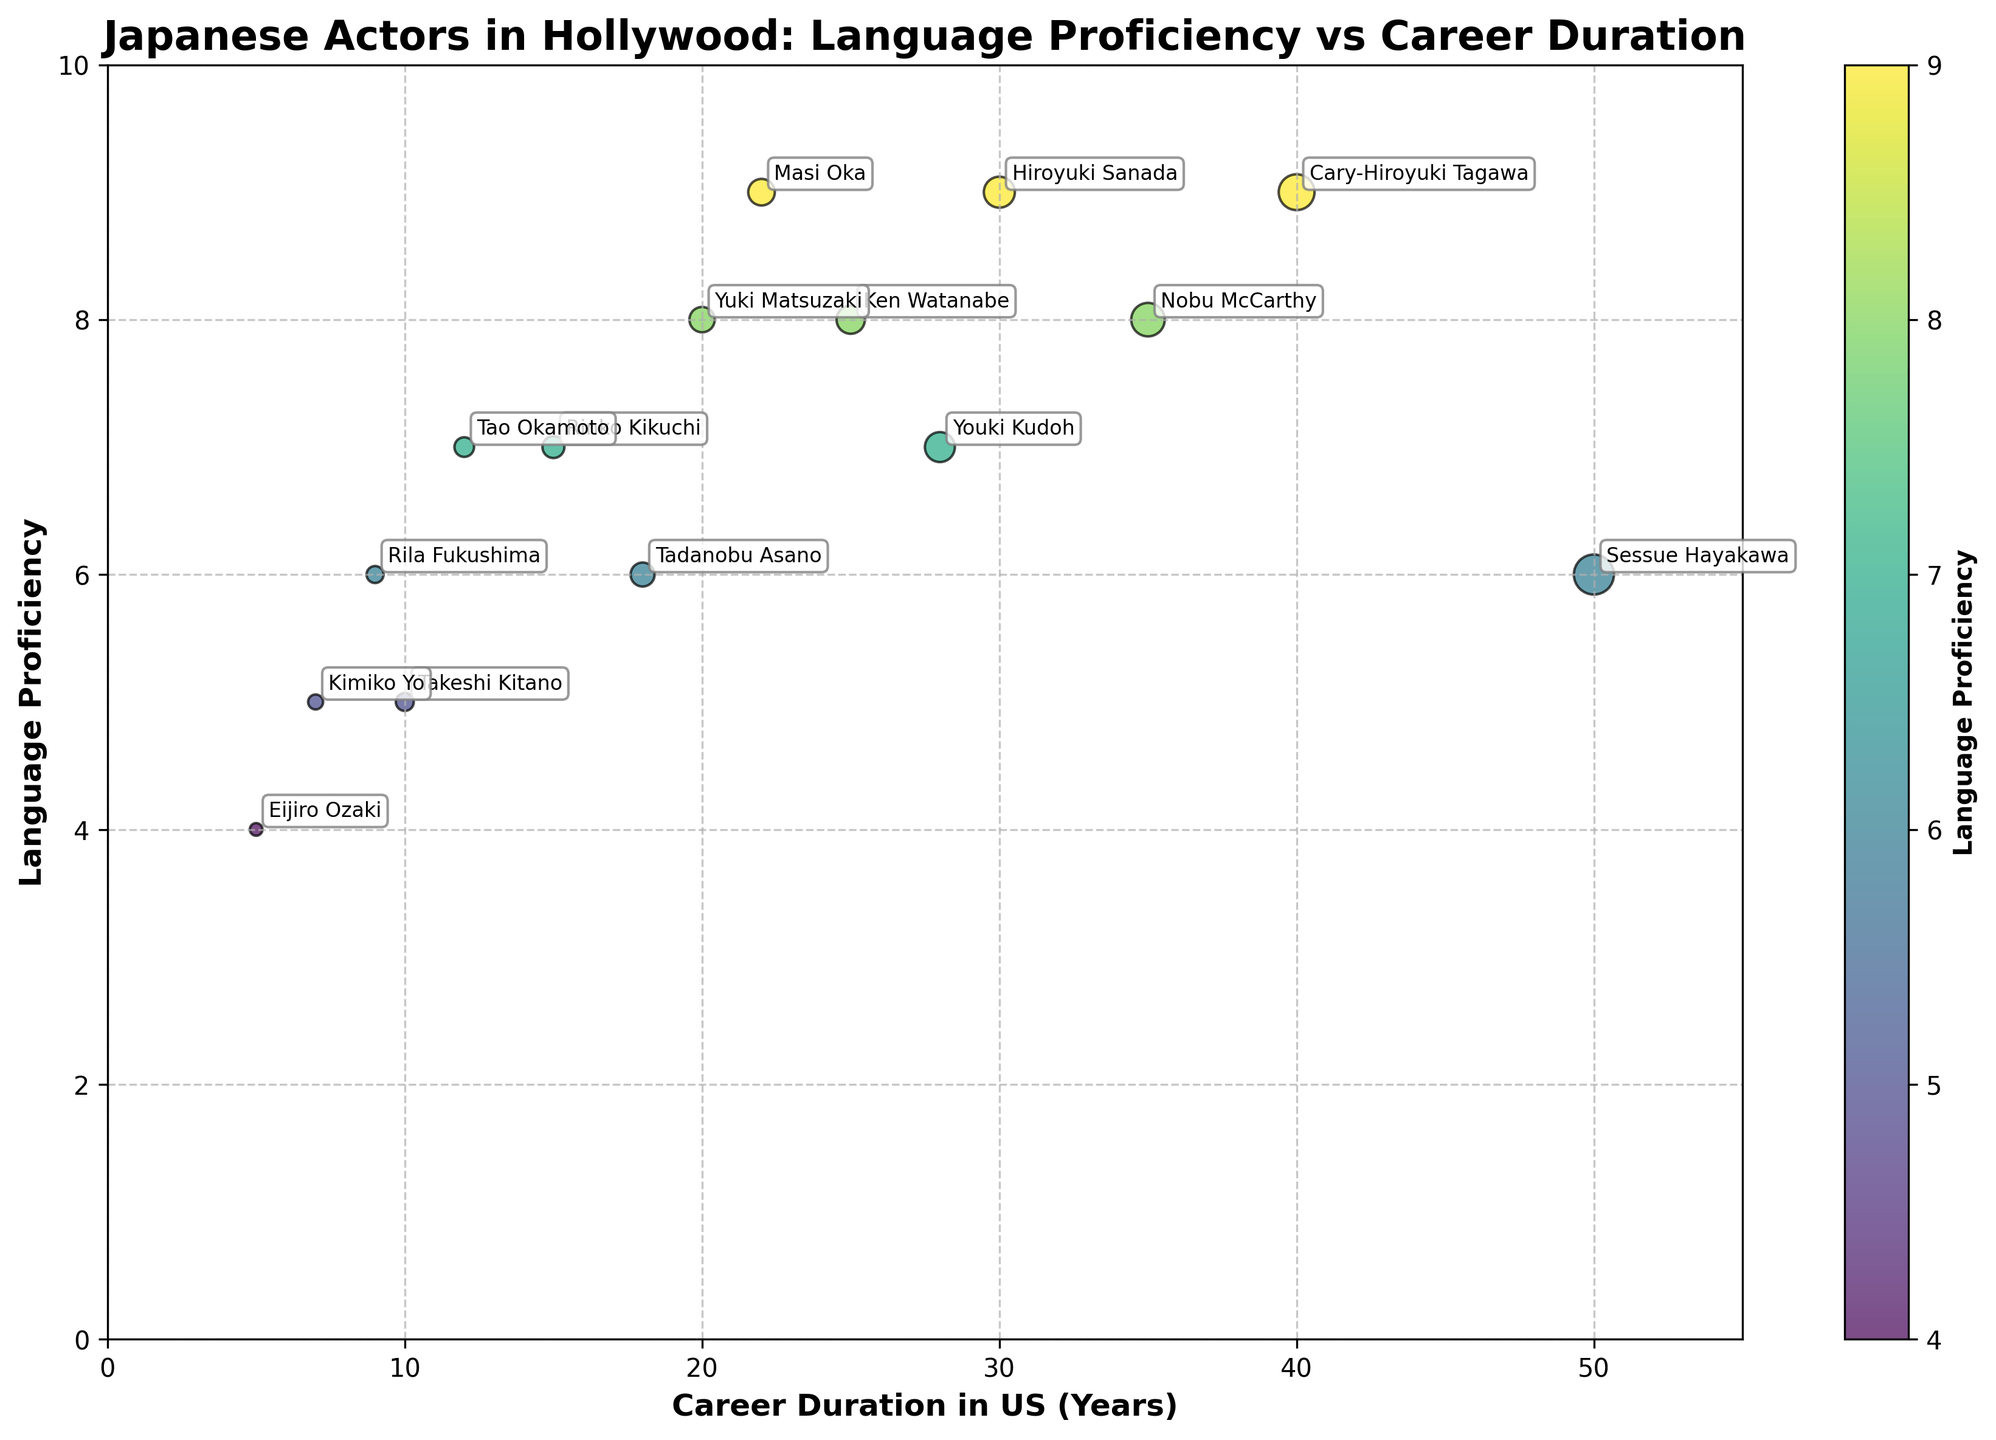How many data points are present in the figure? By looking at the scatter plot, we count the individual dots which each represent a data point. There are 15 actors listed in the data, thus 15 data points are plotted.
Answer: 15 What is the title of the figure? The title of the figure is provided at the top and reads: "Japanese Actors in Hollywood: Language Proficiency vs Career Duration".
Answer: Japanese Actors in Hollywood: Language Proficiency vs Career Duration Which actor has the highest career duration in the US and what is their language proficiency level? By examining the scatter plot, the actor with the highest career duration is found to be at the rightmost point along the x-axis. This actor is Sessue Hayakawa with a career duration of 50 years and a language proficiency level of 6.
Answer: Sessue Hayakawa, 6 Which actor has the lowest language proficiency level and how long is their career duration in the US? The actor with the lowest proficiency level will be at the bottommost point on the y-axis. This actor is Eijiro Ozaki with a language proficiency level of 4 and a career duration of 5 years.
Answer: Eijiro Ozaki, 5 years Who has a language proficiency level of 9 and what are their respective career durations in the US? By identifying the points on the y-axis where Language Proficiency equals 9, we locate the corresponding actors: Hiroyuki Sanada, Masi Oka, and Cary-Hiroyuki Tagawa. Their career durations are 30, 22, and 40 years respectively.
Answer: Hiroyuki Sanada (30 years), Masi Oka (22 years), Cary-Hiroyuki Tagawa (40 years) Which actors have a career duration in the US greater than 20 years? By pinpointing the actors whose points fall beyond the 20-year mark along the x-axis, the actors are identified as Ken Watanabe (25 years), Hiroyuki Sanada (30 years), Yuki Matsuzaki (20 years), Masi Oka (22 years), Cary-Hiroyuki Tagawa (40 years), Youki Kudoh (28 years), and Nobu McCarthy (35 years).
Answer: Ken Watanabe, Hiroyuki Sanada, Masi Oka, Cary-Hiroyuki Tagawa, Youki Kudoh, Nobu McCarthy What is the average career duration of actors with a language proficiency level of 7? Identify all actors with a language proficiency level of 7 and then calculate the average of their career durations. The actors are Rinko Kikuchi (15 years), Tao Okamoto (12 years), and Youki Kudoh (28 years). Average = (15 + 12 + 28) / 3 = 55 / 3 = 18.33 years.
Answer: 18.33 years What is the most common language proficiency level among the actors and how many actors have it? By counting the frequency of each language proficiency level from the y-axis points, the most common level is found to be 8, which is shared by Ken Watanabe, Yuki Matsuzaki, and Nobu McCarthy. There are three actors with this proficiency.
Answer: 8, 3 actors How are the sizes of the points on the scatter plot determined? The size of the points on the scatter plot correlates with the career duration in the US. Larger points signify longer career durations. This reflects that actors with longer careers visually have larger points.
Answer: Career duration in the US Is there a noticeable correlation between language proficiency levels and career duration in the US for Japanese actors? By examining the spread and trend of the data points, one could analyze if higher proficiency correlates with longer careers. While there are actors with both high proficiency and long careers, such as Cary-Hiroyuki Tagawa, the data shows a varied scatter suggesting no strong direct correlation.
Answer: No strong correlation 